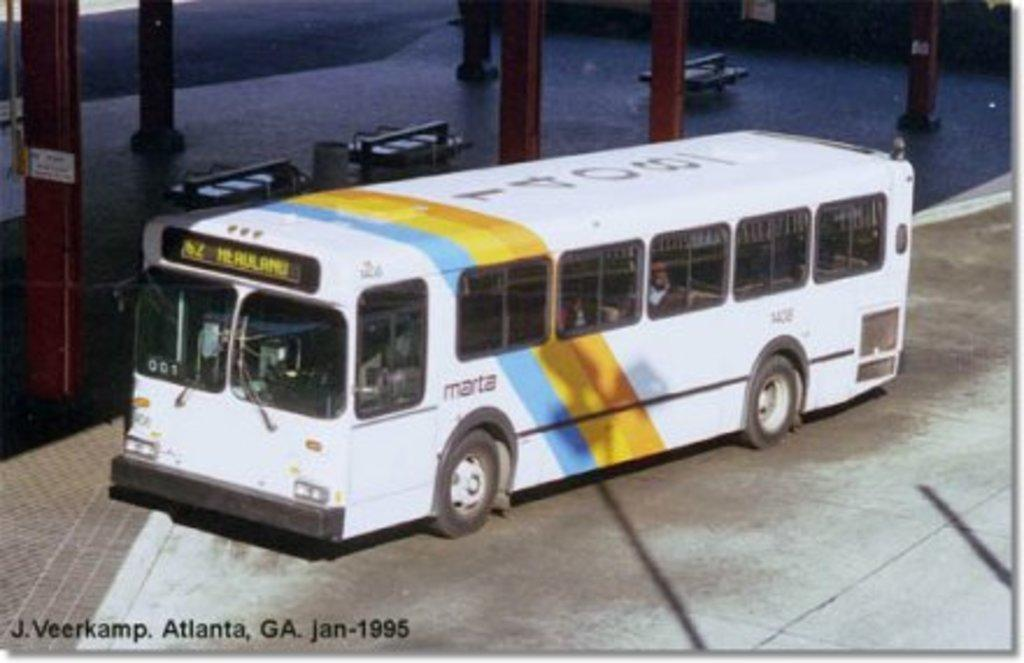<image>
Share a concise interpretation of the image provided. A white bus with orange and blue stripes with the date Jan-1995. 